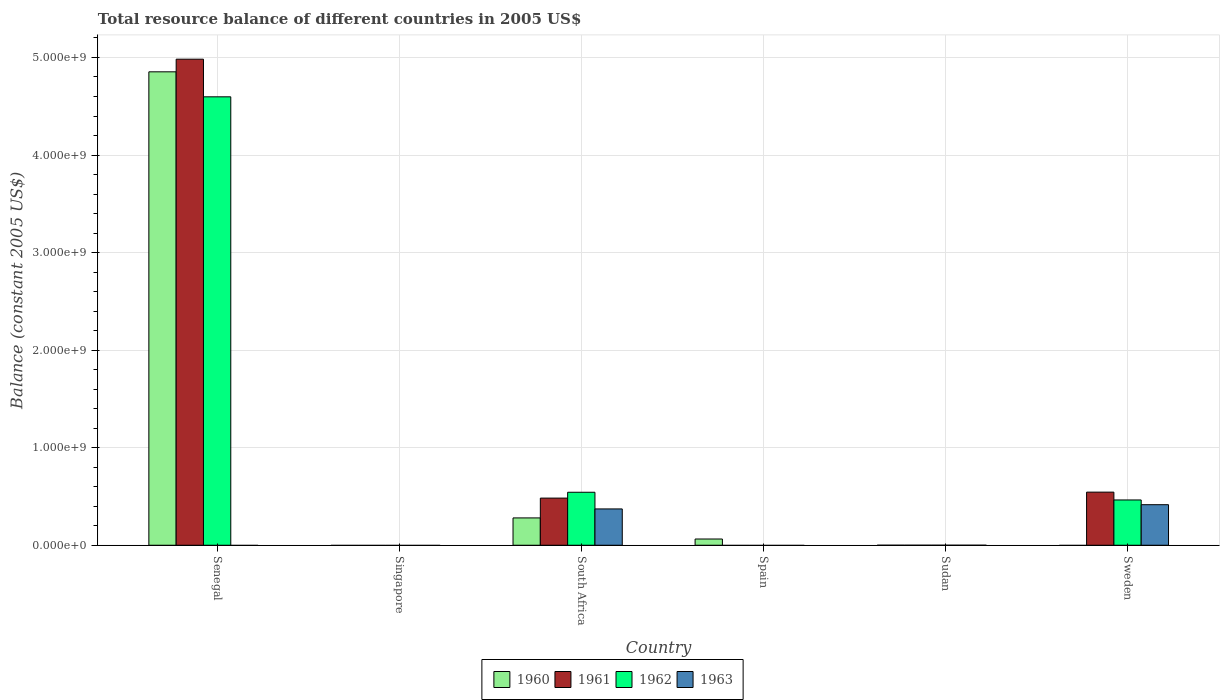Are the number of bars on each tick of the X-axis equal?
Your answer should be very brief. No. How many bars are there on the 2nd tick from the left?
Make the answer very short. 0. How many bars are there on the 6th tick from the right?
Provide a succinct answer. 3. What is the label of the 5th group of bars from the left?
Your answer should be compact. Sudan. In how many cases, is the number of bars for a given country not equal to the number of legend labels?
Offer a terse response. 5. Across all countries, what is the maximum total resource balance in 1963?
Your answer should be very brief. 4.16e+08. What is the total total resource balance in 1961 in the graph?
Your answer should be very brief. 6.01e+09. What is the difference between the total resource balance in 1960 in South Africa and that in Spain?
Your response must be concise. 2.16e+08. What is the difference between the total resource balance in 1961 in Sweden and the total resource balance in 1962 in Spain?
Your response must be concise. 5.44e+08. What is the average total resource balance in 1961 per country?
Your answer should be compact. 1.00e+09. What is the difference between the total resource balance of/in 1961 and total resource balance of/in 1963 in South Africa?
Offer a terse response. 1.11e+08. What is the ratio of the total resource balance in 1961 in South Africa to that in Sweden?
Your answer should be very brief. 0.89. What is the difference between the highest and the second highest total resource balance in 1962?
Offer a terse response. 4.13e+09. What is the difference between the highest and the lowest total resource balance in 1961?
Make the answer very short. 4.98e+09. In how many countries, is the total resource balance in 1962 greater than the average total resource balance in 1962 taken over all countries?
Offer a terse response. 1. How many countries are there in the graph?
Provide a succinct answer. 6. What is the difference between two consecutive major ticks on the Y-axis?
Keep it short and to the point. 1.00e+09. Does the graph contain any zero values?
Provide a short and direct response. Yes. How many legend labels are there?
Offer a terse response. 4. What is the title of the graph?
Ensure brevity in your answer.  Total resource balance of different countries in 2005 US$. What is the label or title of the X-axis?
Provide a succinct answer. Country. What is the label or title of the Y-axis?
Your response must be concise. Balance (constant 2005 US$). What is the Balance (constant 2005 US$) in 1960 in Senegal?
Offer a very short reply. 4.85e+09. What is the Balance (constant 2005 US$) in 1961 in Senegal?
Provide a succinct answer. 4.98e+09. What is the Balance (constant 2005 US$) in 1962 in Senegal?
Your response must be concise. 4.60e+09. What is the Balance (constant 2005 US$) of 1963 in Senegal?
Give a very brief answer. 0. What is the Balance (constant 2005 US$) of 1960 in Singapore?
Provide a succinct answer. 0. What is the Balance (constant 2005 US$) of 1961 in Singapore?
Provide a succinct answer. 0. What is the Balance (constant 2005 US$) of 1960 in South Africa?
Provide a short and direct response. 2.80e+08. What is the Balance (constant 2005 US$) of 1961 in South Africa?
Offer a terse response. 4.83e+08. What is the Balance (constant 2005 US$) in 1962 in South Africa?
Your response must be concise. 5.43e+08. What is the Balance (constant 2005 US$) of 1963 in South Africa?
Offer a terse response. 3.72e+08. What is the Balance (constant 2005 US$) in 1960 in Spain?
Keep it short and to the point. 6.38e+07. What is the Balance (constant 2005 US$) of 1961 in Spain?
Give a very brief answer. 0. What is the Balance (constant 2005 US$) in 1962 in Spain?
Ensure brevity in your answer.  0. What is the Balance (constant 2005 US$) in 1963 in Spain?
Keep it short and to the point. 0. What is the Balance (constant 2005 US$) of 1960 in Sudan?
Offer a terse response. 6100. What is the Balance (constant 2005 US$) in 1961 in Sudan?
Provide a short and direct response. 0. What is the Balance (constant 2005 US$) in 1962 in Sudan?
Make the answer very short. 0. What is the Balance (constant 2005 US$) in 1960 in Sweden?
Provide a succinct answer. 0. What is the Balance (constant 2005 US$) of 1961 in Sweden?
Offer a terse response. 5.44e+08. What is the Balance (constant 2005 US$) in 1962 in Sweden?
Make the answer very short. 4.64e+08. What is the Balance (constant 2005 US$) in 1963 in Sweden?
Provide a short and direct response. 4.16e+08. Across all countries, what is the maximum Balance (constant 2005 US$) in 1960?
Give a very brief answer. 4.85e+09. Across all countries, what is the maximum Balance (constant 2005 US$) of 1961?
Your response must be concise. 4.98e+09. Across all countries, what is the maximum Balance (constant 2005 US$) of 1962?
Make the answer very short. 4.60e+09. Across all countries, what is the maximum Balance (constant 2005 US$) in 1963?
Make the answer very short. 4.16e+08. Across all countries, what is the minimum Balance (constant 2005 US$) of 1962?
Your answer should be compact. 0. What is the total Balance (constant 2005 US$) of 1960 in the graph?
Offer a terse response. 5.20e+09. What is the total Balance (constant 2005 US$) of 1961 in the graph?
Make the answer very short. 6.01e+09. What is the total Balance (constant 2005 US$) in 1962 in the graph?
Make the answer very short. 5.60e+09. What is the total Balance (constant 2005 US$) of 1963 in the graph?
Provide a short and direct response. 7.88e+08. What is the difference between the Balance (constant 2005 US$) in 1960 in Senegal and that in South Africa?
Keep it short and to the point. 4.57e+09. What is the difference between the Balance (constant 2005 US$) in 1961 in Senegal and that in South Africa?
Make the answer very short. 4.50e+09. What is the difference between the Balance (constant 2005 US$) of 1962 in Senegal and that in South Africa?
Your answer should be compact. 4.05e+09. What is the difference between the Balance (constant 2005 US$) of 1960 in Senegal and that in Spain?
Keep it short and to the point. 4.79e+09. What is the difference between the Balance (constant 2005 US$) in 1960 in Senegal and that in Sudan?
Your answer should be very brief. 4.85e+09. What is the difference between the Balance (constant 2005 US$) of 1961 in Senegal and that in Sweden?
Provide a short and direct response. 4.44e+09. What is the difference between the Balance (constant 2005 US$) in 1962 in Senegal and that in Sweden?
Your answer should be very brief. 4.13e+09. What is the difference between the Balance (constant 2005 US$) of 1960 in South Africa and that in Spain?
Make the answer very short. 2.16e+08. What is the difference between the Balance (constant 2005 US$) of 1960 in South Africa and that in Sudan?
Your answer should be compact. 2.80e+08. What is the difference between the Balance (constant 2005 US$) in 1961 in South Africa and that in Sweden?
Your response must be concise. -6.12e+07. What is the difference between the Balance (constant 2005 US$) of 1962 in South Africa and that in Sweden?
Give a very brief answer. 7.89e+07. What is the difference between the Balance (constant 2005 US$) in 1963 in South Africa and that in Sweden?
Make the answer very short. -4.33e+07. What is the difference between the Balance (constant 2005 US$) of 1960 in Spain and that in Sudan?
Offer a very short reply. 6.38e+07. What is the difference between the Balance (constant 2005 US$) in 1960 in Senegal and the Balance (constant 2005 US$) in 1961 in South Africa?
Your answer should be very brief. 4.37e+09. What is the difference between the Balance (constant 2005 US$) of 1960 in Senegal and the Balance (constant 2005 US$) of 1962 in South Africa?
Make the answer very short. 4.31e+09. What is the difference between the Balance (constant 2005 US$) of 1960 in Senegal and the Balance (constant 2005 US$) of 1963 in South Africa?
Offer a very short reply. 4.48e+09. What is the difference between the Balance (constant 2005 US$) in 1961 in Senegal and the Balance (constant 2005 US$) in 1962 in South Africa?
Offer a very short reply. 4.44e+09. What is the difference between the Balance (constant 2005 US$) of 1961 in Senegal and the Balance (constant 2005 US$) of 1963 in South Africa?
Ensure brevity in your answer.  4.61e+09. What is the difference between the Balance (constant 2005 US$) of 1962 in Senegal and the Balance (constant 2005 US$) of 1963 in South Africa?
Offer a terse response. 4.22e+09. What is the difference between the Balance (constant 2005 US$) of 1960 in Senegal and the Balance (constant 2005 US$) of 1961 in Sweden?
Your answer should be compact. 4.31e+09. What is the difference between the Balance (constant 2005 US$) in 1960 in Senegal and the Balance (constant 2005 US$) in 1962 in Sweden?
Your answer should be compact. 4.39e+09. What is the difference between the Balance (constant 2005 US$) of 1960 in Senegal and the Balance (constant 2005 US$) of 1963 in Sweden?
Provide a succinct answer. 4.44e+09. What is the difference between the Balance (constant 2005 US$) of 1961 in Senegal and the Balance (constant 2005 US$) of 1962 in Sweden?
Your answer should be very brief. 4.52e+09. What is the difference between the Balance (constant 2005 US$) in 1961 in Senegal and the Balance (constant 2005 US$) in 1963 in Sweden?
Make the answer very short. 4.57e+09. What is the difference between the Balance (constant 2005 US$) in 1962 in Senegal and the Balance (constant 2005 US$) in 1963 in Sweden?
Give a very brief answer. 4.18e+09. What is the difference between the Balance (constant 2005 US$) of 1960 in South Africa and the Balance (constant 2005 US$) of 1961 in Sweden?
Offer a very short reply. -2.64e+08. What is the difference between the Balance (constant 2005 US$) in 1960 in South Africa and the Balance (constant 2005 US$) in 1962 in Sweden?
Give a very brief answer. -1.84e+08. What is the difference between the Balance (constant 2005 US$) in 1960 in South Africa and the Balance (constant 2005 US$) in 1963 in Sweden?
Your response must be concise. -1.35e+08. What is the difference between the Balance (constant 2005 US$) in 1961 in South Africa and the Balance (constant 2005 US$) in 1962 in Sweden?
Provide a succinct answer. 1.91e+07. What is the difference between the Balance (constant 2005 US$) of 1961 in South Africa and the Balance (constant 2005 US$) of 1963 in Sweden?
Provide a succinct answer. 6.77e+07. What is the difference between the Balance (constant 2005 US$) in 1962 in South Africa and the Balance (constant 2005 US$) in 1963 in Sweden?
Ensure brevity in your answer.  1.28e+08. What is the difference between the Balance (constant 2005 US$) of 1960 in Spain and the Balance (constant 2005 US$) of 1961 in Sweden?
Offer a terse response. -4.81e+08. What is the difference between the Balance (constant 2005 US$) of 1960 in Spain and the Balance (constant 2005 US$) of 1962 in Sweden?
Give a very brief answer. -4.00e+08. What is the difference between the Balance (constant 2005 US$) of 1960 in Spain and the Balance (constant 2005 US$) of 1963 in Sweden?
Keep it short and to the point. -3.52e+08. What is the difference between the Balance (constant 2005 US$) in 1960 in Sudan and the Balance (constant 2005 US$) in 1961 in Sweden?
Your answer should be compact. -5.44e+08. What is the difference between the Balance (constant 2005 US$) in 1960 in Sudan and the Balance (constant 2005 US$) in 1962 in Sweden?
Your response must be concise. -4.64e+08. What is the difference between the Balance (constant 2005 US$) in 1960 in Sudan and the Balance (constant 2005 US$) in 1963 in Sweden?
Provide a succinct answer. -4.16e+08. What is the average Balance (constant 2005 US$) in 1960 per country?
Provide a succinct answer. 8.66e+08. What is the average Balance (constant 2005 US$) of 1961 per country?
Your response must be concise. 1.00e+09. What is the average Balance (constant 2005 US$) of 1962 per country?
Offer a terse response. 9.34e+08. What is the average Balance (constant 2005 US$) of 1963 per country?
Offer a very short reply. 1.31e+08. What is the difference between the Balance (constant 2005 US$) of 1960 and Balance (constant 2005 US$) of 1961 in Senegal?
Your answer should be very brief. -1.30e+08. What is the difference between the Balance (constant 2005 US$) of 1960 and Balance (constant 2005 US$) of 1962 in Senegal?
Your response must be concise. 2.56e+08. What is the difference between the Balance (constant 2005 US$) in 1961 and Balance (constant 2005 US$) in 1962 in Senegal?
Your answer should be compact. 3.86e+08. What is the difference between the Balance (constant 2005 US$) in 1960 and Balance (constant 2005 US$) in 1961 in South Africa?
Your response must be concise. -2.03e+08. What is the difference between the Balance (constant 2005 US$) in 1960 and Balance (constant 2005 US$) in 1962 in South Africa?
Provide a succinct answer. -2.63e+08. What is the difference between the Balance (constant 2005 US$) of 1960 and Balance (constant 2005 US$) of 1963 in South Africa?
Your answer should be very brief. -9.21e+07. What is the difference between the Balance (constant 2005 US$) of 1961 and Balance (constant 2005 US$) of 1962 in South Africa?
Keep it short and to the point. -5.99e+07. What is the difference between the Balance (constant 2005 US$) of 1961 and Balance (constant 2005 US$) of 1963 in South Africa?
Ensure brevity in your answer.  1.11e+08. What is the difference between the Balance (constant 2005 US$) in 1962 and Balance (constant 2005 US$) in 1963 in South Africa?
Your response must be concise. 1.71e+08. What is the difference between the Balance (constant 2005 US$) in 1961 and Balance (constant 2005 US$) in 1962 in Sweden?
Give a very brief answer. 8.03e+07. What is the difference between the Balance (constant 2005 US$) in 1961 and Balance (constant 2005 US$) in 1963 in Sweden?
Your answer should be very brief. 1.29e+08. What is the difference between the Balance (constant 2005 US$) in 1962 and Balance (constant 2005 US$) in 1963 in Sweden?
Make the answer very short. 4.86e+07. What is the ratio of the Balance (constant 2005 US$) of 1960 in Senegal to that in South Africa?
Ensure brevity in your answer.  17.33. What is the ratio of the Balance (constant 2005 US$) in 1961 in Senegal to that in South Africa?
Your answer should be very brief. 10.31. What is the ratio of the Balance (constant 2005 US$) in 1962 in Senegal to that in South Africa?
Make the answer very short. 8.46. What is the ratio of the Balance (constant 2005 US$) of 1960 in Senegal to that in Spain?
Give a very brief answer. 76.07. What is the ratio of the Balance (constant 2005 US$) of 1960 in Senegal to that in Sudan?
Provide a short and direct response. 7.96e+05. What is the ratio of the Balance (constant 2005 US$) of 1961 in Senegal to that in Sweden?
Your answer should be compact. 9.15. What is the ratio of the Balance (constant 2005 US$) of 1962 in Senegal to that in Sweden?
Make the answer very short. 9.9. What is the ratio of the Balance (constant 2005 US$) in 1960 in South Africa to that in Spain?
Provide a succinct answer. 4.39. What is the ratio of the Balance (constant 2005 US$) in 1960 in South Africa to that in Sudan?
Provide a succinct answer. 4.59e+04. What is the ratio of the Balance (constant 2005 US$) of 1961 in South Africa to that in Sweden?
Your answer should be compact. 0.89. What is the ratio of the Balance (constant 2005 US$) in 1962 in South Africa to that in Sweden?
Give a very brief answer. 1.17. What is the ratio of the Balance (constant 2005 US$) in 1963 in South Africa to that in Sweden?
Your answer should be compact. 0.9. What is the ratio of the Balance (constant 2005 US$) of 1960 in Spain to that in Sudan?
Your answer should be compact. 1.05e+04. What is the difference between the highest and the second highest Balance (constant 2005 US$) of 1960?
Your answer should be compact. 4.57e+09. What is the difference between the highest and the second highest Balance (constant 2005 US$) in 1961?
Your answer should be very brief. 4.44e+09. What is the difference between the highest and the second highest Balance (constant 2005 US$) in 1962?
Keep it short and to the point. 4.05e+09. What is the difference between the highest and the lowest Balance (constant 2005 US$) of 1960?
Keep it short and to the point. 4.85e+09. What is the difference between the highest and the lowest Balance (constant 2005 US$) of 1961?
Make the answer very short. 4.98e+09. What is the difference between the highest and the lowest Balance (constant 2005 US$) of 1962?
Ensure brevity in your answer.  4.60e+09. What is the difference between the highest and the lowest Balance (constant 2005 US$) of 1963?
Ensure brevity in your answer.  4.16e+08. 